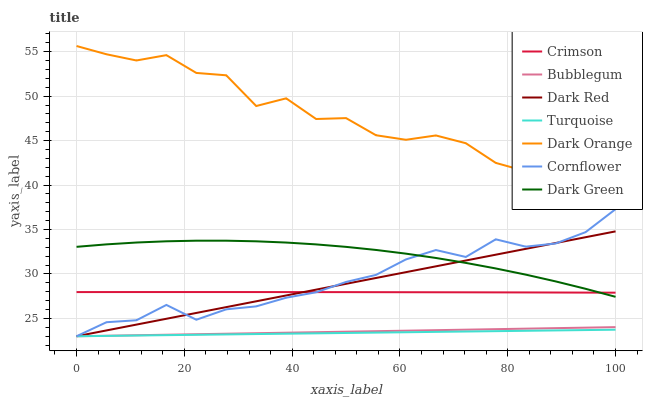Does Turquoise have the minimum area under the curve?
Answer yes or no. Yes. Does Dark Orange have the maximum area under the curve?
Answer yes or no. Yes. Does Dark Orange have the minimum area under the curve?
Answer yes or no. No. Does Turquoise have the maximum area under the curve?
Answer yes or no. No. Is Bubblegum the smoothest?
Answer yes or no. Yes. Is Dark Orange the roughest?
Answer yes or no. Yes. Is Turquoise the smoothest?
Answer yes or no. No. Is Turquoise the roughest?
Answer yes or no. No. Does Cornflower have the lowest value?
Answer yes or no. Yes. Does Dark Orange have the lowest value?
Answer yes or no. No. Does Dark Orange have the highest value?
Answer yes or no. Yes. Does Turquoise have the highest value?
Answer yes or no. No. Is Bubblegum less than Dark Orange?
Answer yes or no. Yes. Is Dark Green greater than Turquoise?
Answer yes or no. Yes. Does Crimson intersect Dark Red?
Answer yes or no. Yes. Is Crimson less than Dark Red?
Answer yes or no. No. Is Crimson greater than Dark Red?
Answer yes or no. No. Does Bubblegum intersect Dark Orange?
Answer yes or no. No. 